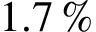Convert formula to latex. <formula><loc_0><loc_0><loc_500><loc_500>1 . 7 \, \%</formula> 